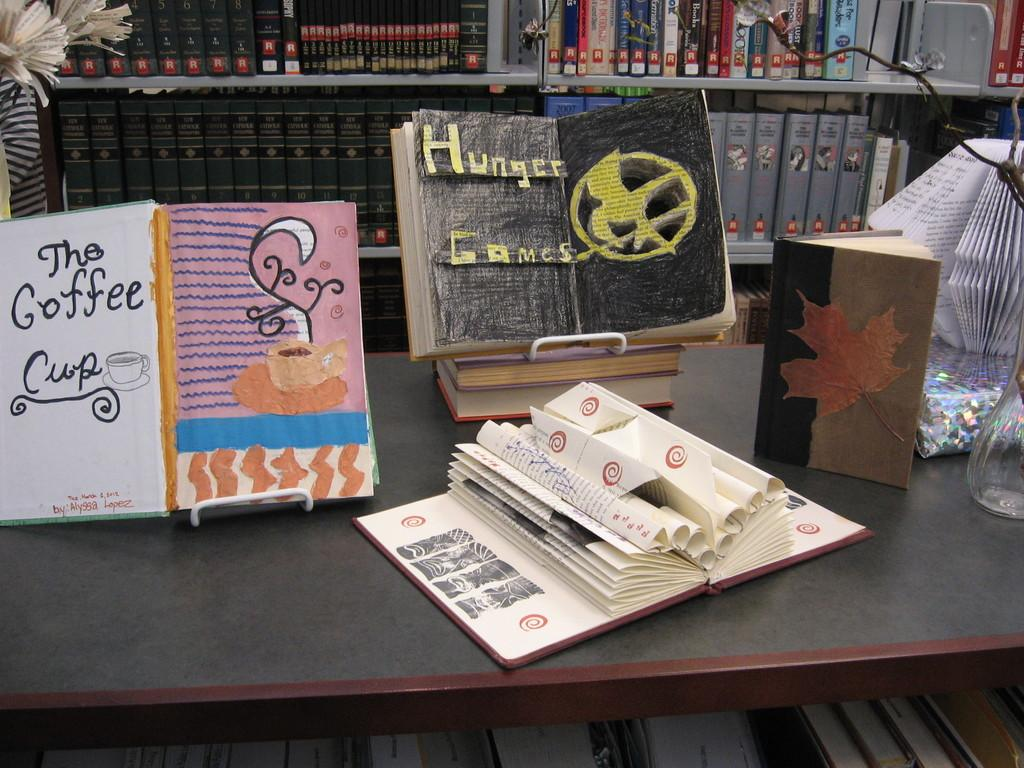Provide a one-sentence caption for the provided image. The art in the middle is for the series Hunger Games. 